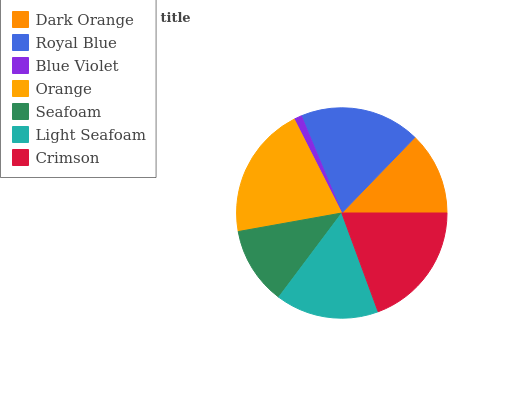Is Blue Violet the minimum?
Answer yes or no. Yes. Is Orange the maximum?
Answer yes or no. Yes. Is Royal Blue the minimum?
Answer yes or no. No. Is Royal Blue the maximum?
Answer yes or no. No. Is Royal Blue greater than Dark Orange?
Answer yes or no. Yes. Is Dark Orange less than Royal Blue?
Answer yes or no. Yes. Is Dark Orange greater than Royal Blue?
Answer yes or no. No. Is Royal Blue less than Dark Orange?
Answer yes or no. No. Is Light Seafoam the high median?
Answer yes or no. Yes. Is Light Seafoam the low median?
Answer yes or no. Yes. Is Dark Orange the high median?
Answer yes or no. No. Is Dark Orange the low median?
Answer yes or no. No. 